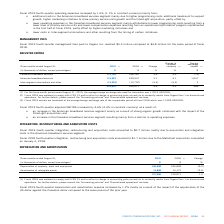According to Cogeco's financial document, What was the exchange rate in 2019? According to the financial document, 1.3222 USD/CDN.. The relevant text states: "age foreign exchange rate used for translation was 1.3222 USD/CDN...." Also, What was the exchange rate in 2018? According to the financial document, 1.3100 USD/CDN.. The relevant text states: "of the comparable period of fiscal 2018 which was 1.3100 USD/CDN...." Also, What was the increase in EBITDA in fourth-quarter 2019? According to the financial document, 4.6%. The relevant text states: "l 2019 fourth-quarter adjusted EBITDA increased by 4.6% (4.3% in constant currency) as a result of:..." Also, can you calculate: What is the increase / (decrease) in the Canadian broadband services from 2018 to 2019? Based on the calculation: 172,120 - 166,181, the result is 5939 (in thousands). This is based on the information: "Canadian broadband services 172,120 166,181 3.6 3.6 (73) Canadian broadband services 172,120 166,181 3.6 3.6 (73)..." The key data points involved are: 166,181, 172,120. Also, can you calculate: What was the average Canadian broadband services? To answer this question, I need to perform calculations using the financial data. The calculation is: (172,120 + 166,181) / 2, which equals 169150.5 (in thousands). This is based on the information: "Canadian broadband services 172,120 166,181 3.6 3.6 (73) Canadian broadband services 172,120 166,181 3.6 3.6 (73)..." The key data points involved are: 166,181, 172,120. Also, can you calculate: What was the average American broadband services from 2018 to 2019? To answer this question, I need to perform calculations using the financial data. The calculation is: (115,523 + 109,937) / 2, which equals 112730 (in thousands). This is based on the information: "American broadband services 115,523 109,937 5.1 4.1 1,057 American broadband services 115,523 109,937 5.1 4.1 1,057..." The key data points involved are: 109,937, 115,523. 